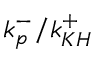<formula> <loc_0><loc_0><loc_500><loc_500>k _ { p } ^ { - } / k _ { K H } ^ { + }</formula> 